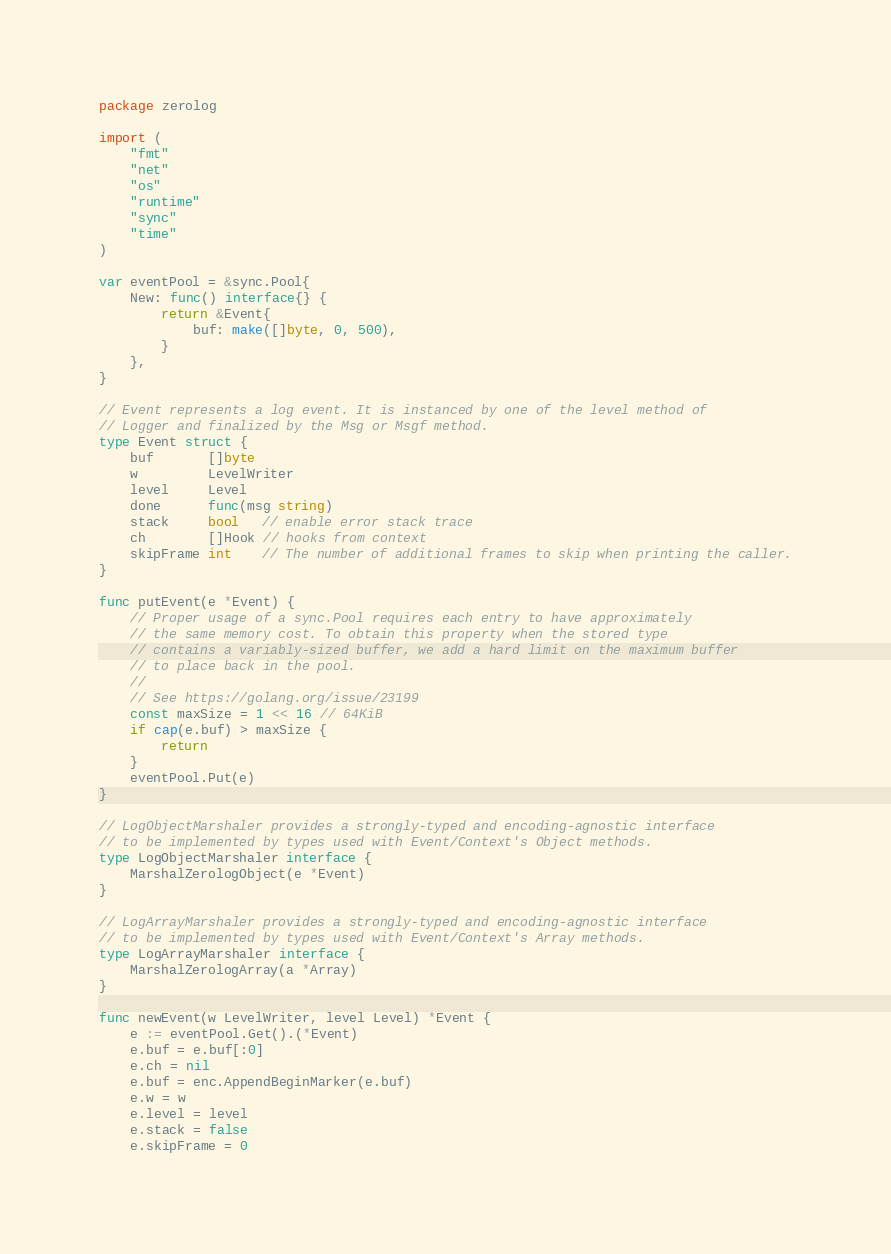<code> <loc_0><loc_0><loc_500><loc_500><_Go_>package zerolog

import (
	"fmt"
	"net"
	"os"
	"runtime"
	"sync"
	"time"
)

var eventPool = &sync.Pool{
	New: func() interface{} {
		return &Event{
			buf: make([]byte, 0, 500),
		}
	},
}

// Event represents a log event. It is instanced by one of the level method of
// Logger and finalized by the Msg or Msgf method.
type Event struct {
	buf       []byte
	w         LevelWriter
	level     Level
	done      func(msg string)
	stack     bool   // enable error stack trace
	ch        []Hook // hooks from context
	skipFrame int    // The number of additional frames to skip when printing the caller.
}

func putEvent(e *Event) {
	// Proper usage of a sync.Pool requires each entry to have approximately
	// the same memory cost. To obtain this property when the stored type
	// contains a variably-sized buffer, we add a hard limit on the maximum buffer
	// to place back in the pool.
	//
	// See https://golang.org/issue/23199
	const maxSize = 1 << 16 // 64KiB
	if cap(e.buf) > maxSize {
		return
	}
	eventPool.Put(e)
}

// LogObjectMarshaler provides a strongly-typed and encoding-agnostic interface
// to be implemented by types used with Event/Context's Object methods.
type LogObjectMarshaler interface {
	MarshalZerologObject(e *Event)
}

// LogArrayMarshaler provides a strongly-typed and encoding-agnostic interface
// to be implemented by types used with Event/Context's Array methods.
type LogArrayMarshaler interface {
	MarshalZerologArray(a *Array)
}

func newEvent(w LevelWriter, level Level) *Event {
	e := eventPool.Get().(*Event)
	e.buf = e.buf[:0]
	e.ch = nil
	e.buf = enc.AppendBeginMarker(e.buf)
	e.w = w
	e.level = level
	e.stack = false
	e.skipFrame = 0</code> 